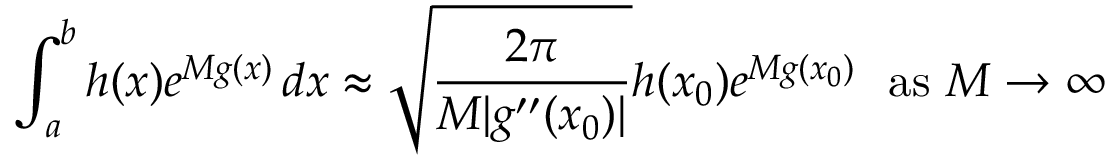<formula> <loc_0><loc_0><loc_500><loc_500>\int _ { a } ^ { b } h ( x ) e ^ { M g ( x ) } \, d x \approx { \sqrt { \frac { 2 \pi } { M | g ^ { \prime \prime } ( x _ { 0 } ) | } } } h ( x _ { 0 } ) e ^ { M g ( x _ { 0 } ) } \ { a s } M \to \infty</formula> 